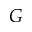Convert formula to latex. <formula><loc_0><loc_0><loc_500><loc_500>G</formula> 